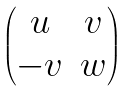<formula> <loc_0><loc_0><loc_500><loc_500>\begin{pmatrix} u & v \\ - v & w \end{pmatrix}</formula> 